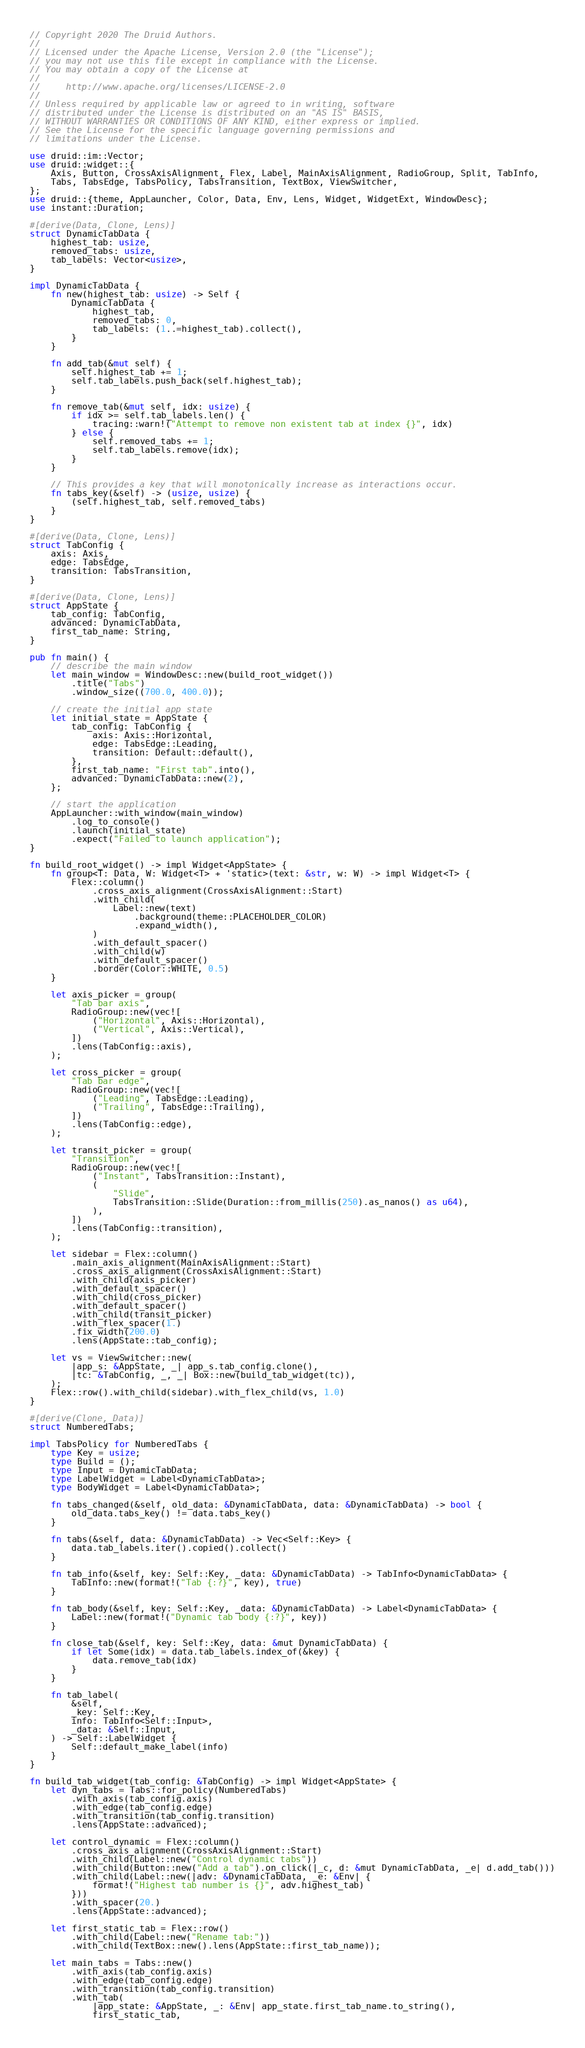<code> <loc_0><loc_0><loc_500><loc_500><_Rust_>// Copyright 2020 The Druid Authors.
//
// Licensed under the Apache License, Version 2.0 (the "License");
// you may not use this file except in compliance with the License.
// You may obtain a copy of the License at
//
//     http://www.apache.org/licenses/LICENSE-2.0
//
// Unless required by applicable law or agreed to in writing, software
// distributed under the License is distributed on an "AS IS" BASIS,
// WITHOUT WARRANTIES OR CONDITIONS OF ANY KIND, either express or implied.
// See the License for the specific language governing permissions and
// limitations under the License.

use druid::im::Vector;
use druid::widget::{
    Axis, Button, CrossAxisAlignment, Flex, Label, MainAxisAlignment, RadioGroup, Split, TabInfo,
    Tabs, TabsEdge, TabsPolicy, TabsTransition, TextBox, ViewSwitcher,
};
use druid::{theme, AppLauncher, Color, Data, Env, Lens, Widget, WidgetExt, WindowDesc};
use instant::Duration;

#[derive(Data, Clone, Lens)]
struct DynamicTabData {
    highest_tab: usize,
    removed_tabs: usize,
    tab_labels: Vector<usize>,
}

impl DynamicTabData {
    fn new(highest_tab: usize) -> Self {
        DynamicTabData {
            highest_tab,
            removed_tabs: 0,
            tab_labels: (1..=highest_tab).collect(),
        }
    }

    fn add_tab(&mut self) {
        self.highest_tab += 1;
        self.tab_labels.push_back(self.highest_tab);
    }

    fn remove_tab(&mut self, idx: usize) {
        if idx >= self.tab_labels.len() {
            tracing::warn!("Attempt to remove non existent tab at index {}", idx)
        } else {
            self.removed_tabs += 1;
            self.tab_labels.remove(idx);
        }
    }

    // This provides a key that will monotonically increase as interactions occur.
    fn tabs_key(&self) -> (usize, usize) {
        (self.highest_tab, self.removed_tabs)
    }
}

#[derive(Data, Clone, Lens)]
struct TabConfig {
    axis: Axis,
    edge: TabsEdge,
    transition: TabsTransition,
}

#[derive(Data, Clone, Lens)]
struct AppState {
    tab_config: TabConfig,
    advanced: DynamicTabData,
    first_tab_name: String,
}

pub fn main() {
    // describe the main window
    let main_window = WindowDesc::new(build_root_widget())
        .title("Tabs")
        .window_size((700.0, 400.0));

    // create the initial app state
    let initial_state = AppState {
        tab_config: TabConfig {
            axis: Axis::Horizontal,
            edge: TabsEdge::Leading,
            transition: Default::default(),
        },
        first_tab_name: "First tab".into(),
        advanced: DynamicTabData::new(2),
    };

    // start the application
    AppLauncher::with_window(main_window)
        .log_to_console()
        .launch(initial_state)
        .expect("Failed to launch application");
}

fn build_root_widget() -> impl Widget<AppState> {
    fn group<T: Data, W: Widget<T> + 'static>(text: &str, w: W) -> impl Widget<T> {
        Flex::column()
            .cross_axis_alignment(CrossAxisAlignment::Start)
            .with_child(
                Label::new(text)
                    .background(theme::PLACEHOLDER_COLOR)
                    .expand_width(),
            )
            .with_default_spacer()
            .with_child(w)
            .with_default_spacer()
            .border(Color::WHITE, 0.5)
    }

    let axis_picker = group(
        "Tab bar axis",
        RadioGroup::new(vec![
            ("Horizontal", Axis::Horizontal),
            ("Vertical", Axis::Vertical),
        ])
        .lens(TabConfig::axis),
    );

    let cross_picker = group(
        "Tab bar edge",
        RadioGroup::new(vec![
            ("Leading", TabsEdge::Leading),
            ("Trailing", TabsEdge::Trailing),
        ])
        .lens(TabConfig::edge),
    );

    let transit_picker = group(
        "Transition",
        RadioGroup::new(vec![
            ("Instant", TabsTransition::Instant),
            (
                "Slide",
                TabsTransition::Slide(Duration::from_millis(250).as_nanos() as u64),
            ),
        ])
        .lens(TabConfig::transition),
    );

    let sidebar = Flex::column()
        .main_axis_alignment(MainAxisAlignment::Start)
        .cross_axis_alignment(CrossAxisAlignment::Start)
        .with_child(axis_picker)
        .with_default_spacer()
        .with_child(cross_picker)
        .with_default_spacer()
        .with_child(transit_picker)
        .with_flex_spacer(1.)
        .fix_width(200.0)
        .lens(AppState::tab_config);

    let vs = ViewSwitcher::new(
        |app_s: &AppState, _| app_s.tab_config.clone(),
        |tc: &TabConfig, _, _| Box::new(build_tab_widget(tc)),
    );
    Flex::row().with_child(sidebar).with_flex_child(vs, 1.0)
}

#[derive(Clone, Data)]
struct NumberedTabs;

impl TabsPolicy for NumberedTabs {
    type Key = usize;
    type Build = ();
    type Input = DynamicTabData;
    type LabelWidget = Label<DynamicTabData>;
    type BodyWidget = Label<DynamicTabData>;

    fn tabs_changed(&self, old_data: &DynamicTabData, data: &DynamicTabData) -> bool {
        old_data.tabs_key() != data.tabs_key()
    }

    fn tabs(&self, data: &DynamicTabData) -> Vec<Self::Key> {
        data.tab_labels.iter().copied().collect()
    }

    fn tab_info(&self, key: Self::Key, _data: &DynamicTabData) -> TabInfo<DynamicTabData> {
        TabInfo::new(format!("Tab {:?}", key), true)
    }

    fn tab_body(&self, key: Self::Key, _data: &DynamicTabData) -> Label<DynamicTabData> {
        Label::new(format!("Dynamic tab body {:?}", key))
    }

    fn close_tab(&self, key: Self::Key, data: &mut DynamicTabData) {
        if let Some(idx) = data.tab_labels.index_of(&key) {
            data.remove_tab(idx)
        }
    }

    fn tab_label(
        &self,
        _key: Self::Key,
        info: TabInfo<Self::Input>,
        _data: &Self::Input,
    ) -> Self::LabelWidget {
        Self::default_make_label(info)
    }
}

fn build_tab_widget(tab_config: &TabConfig) -> impl Widget<AppState> {
    let dyn_tabs = Tabs::for_policy(NumberedTabs)
        .with_axis(tab_config.axis)
        .with_edge(tab_config.edge)
        .with_transition(tab_config.transition)
        .lens(AppState::advanced);

    let control_dynamic = Flex::column()
        .cross_axis_alignment(CrossAxisAlignment::Start)
        .with_child(Label::new("Control dynamic tabs"))
        .with_child(Button::new("Add a tab").on_click(|_c, d: &mut DynamicTabData, _e| d.add_tab()))
        .with_child(Label::new(|adv: &DynamicTabData, _e: &Env| {
            format!("Highest tab number is {}", adv.highest_tab)
        }))
        .with_spacer(20.)
        .lens(AppState::advanced);

    let first_static_tab = Flex::row()
        .with_child(Label::new("Rename tab:"))
        .with_child(TextBox::new().lens(AppState::first_tab_name));

    let main_tabs = Tabs::new()
        .with_axis(tab_config.axis)
        .with_edge(tab_config.edge)
        .with_transition(tab_config.transition)
        .with_tab(
            |app_state: &AppState, _: &Env| app_state.first_tab_name.to_string(),
            first_static_tab,</code> 